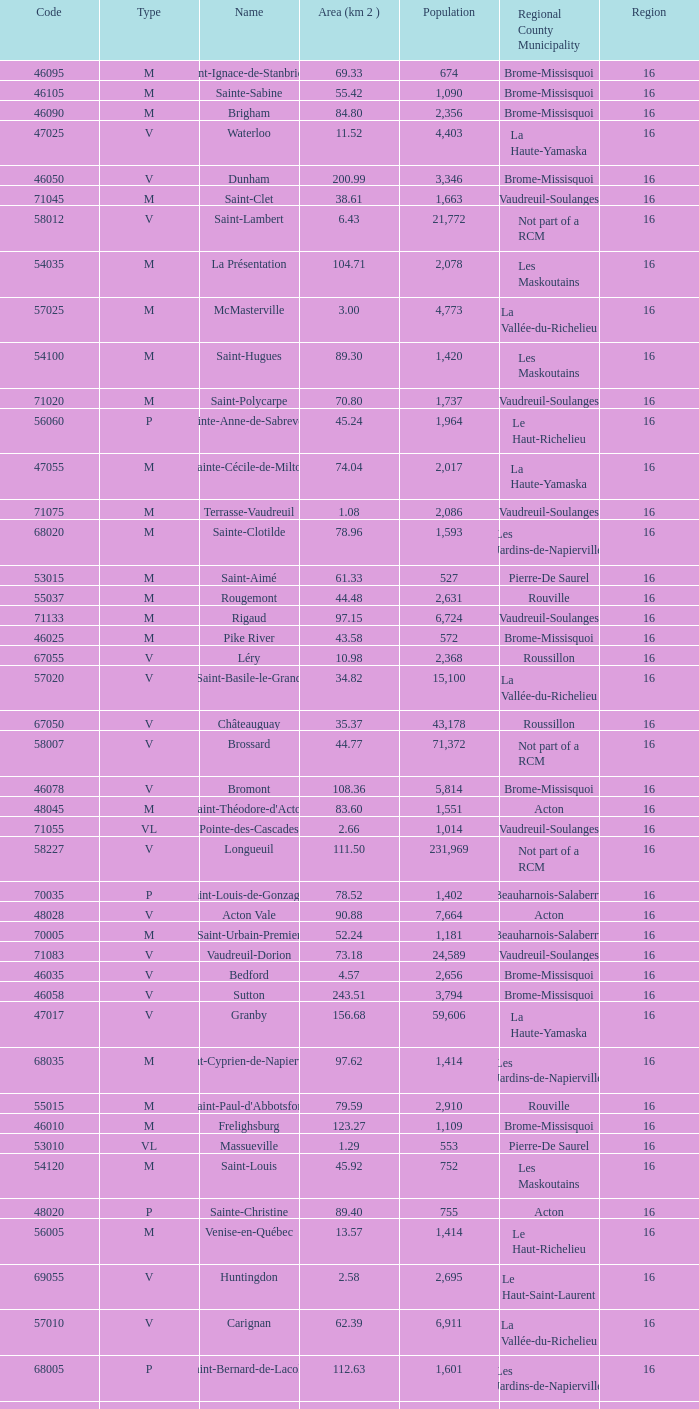What is the code for a Le Haut-Saint-Laurent municipality that has 16 or more regions? None. 